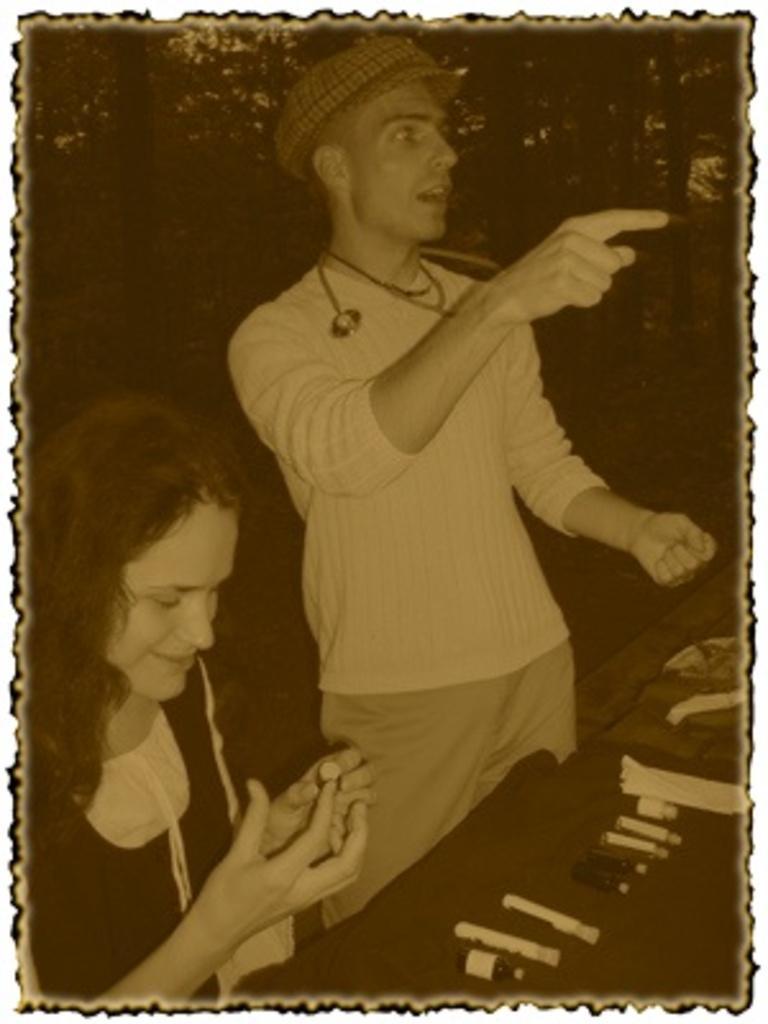How would you summarize this image in a sentence or two? In the middle of the image, there is a person in a t-shirt, standing and speaking. Beside him, there is a woman smiling. In front of her, there is an object. And the background is dark in color. 